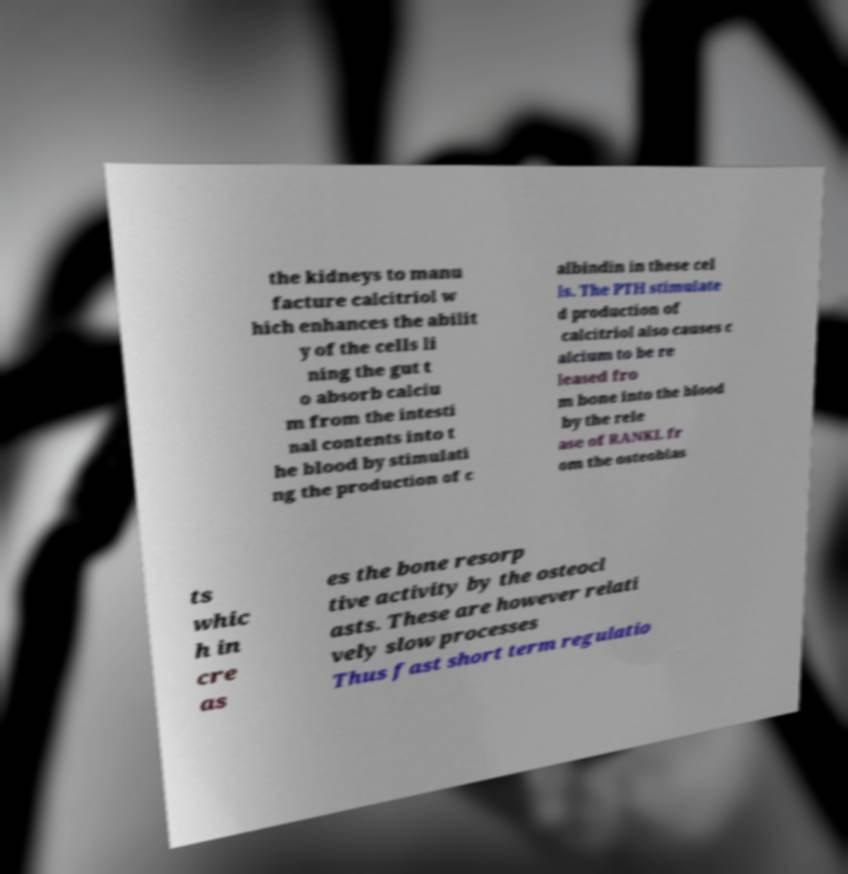Could you assist in decoding the text presented in this image and type it out clearly? the kidneys to manu facture calcitriol w hich enhances the abilit y of the cells li ning the gut t o absorb calciu m from the intesti nal contents into t he blood by stimulati ng the production of c albindin in these cel ls. The PTH stimulate d production of calcitriol also causes c alcium to be re leased fro m bone into the blood by the rele ase of RANKL fr om the osteoblas ts whic h in cre as es the bone resorp tive activity by the osteocl asts. These are however relati vely slow processes Thus fast short term regulatio 